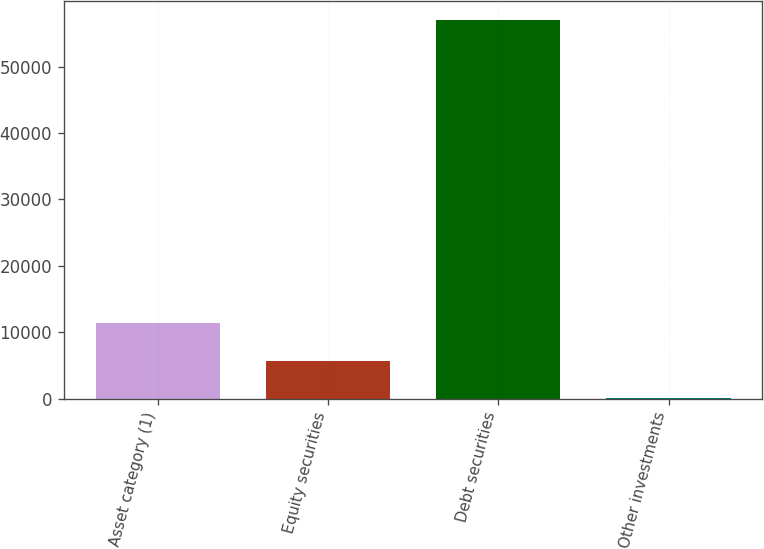Convert chart to OTSL. <chart><loc_0><loc_0><loc_500><loc_500><bar_chart><fcel>Asset category (1)<fcel>Equity securities<fcel>Debt securities<fcel>Other investments<nl><fcel>11423.2<fcel>5713.6<fcel>57100<fcel>4<nl></chart> 